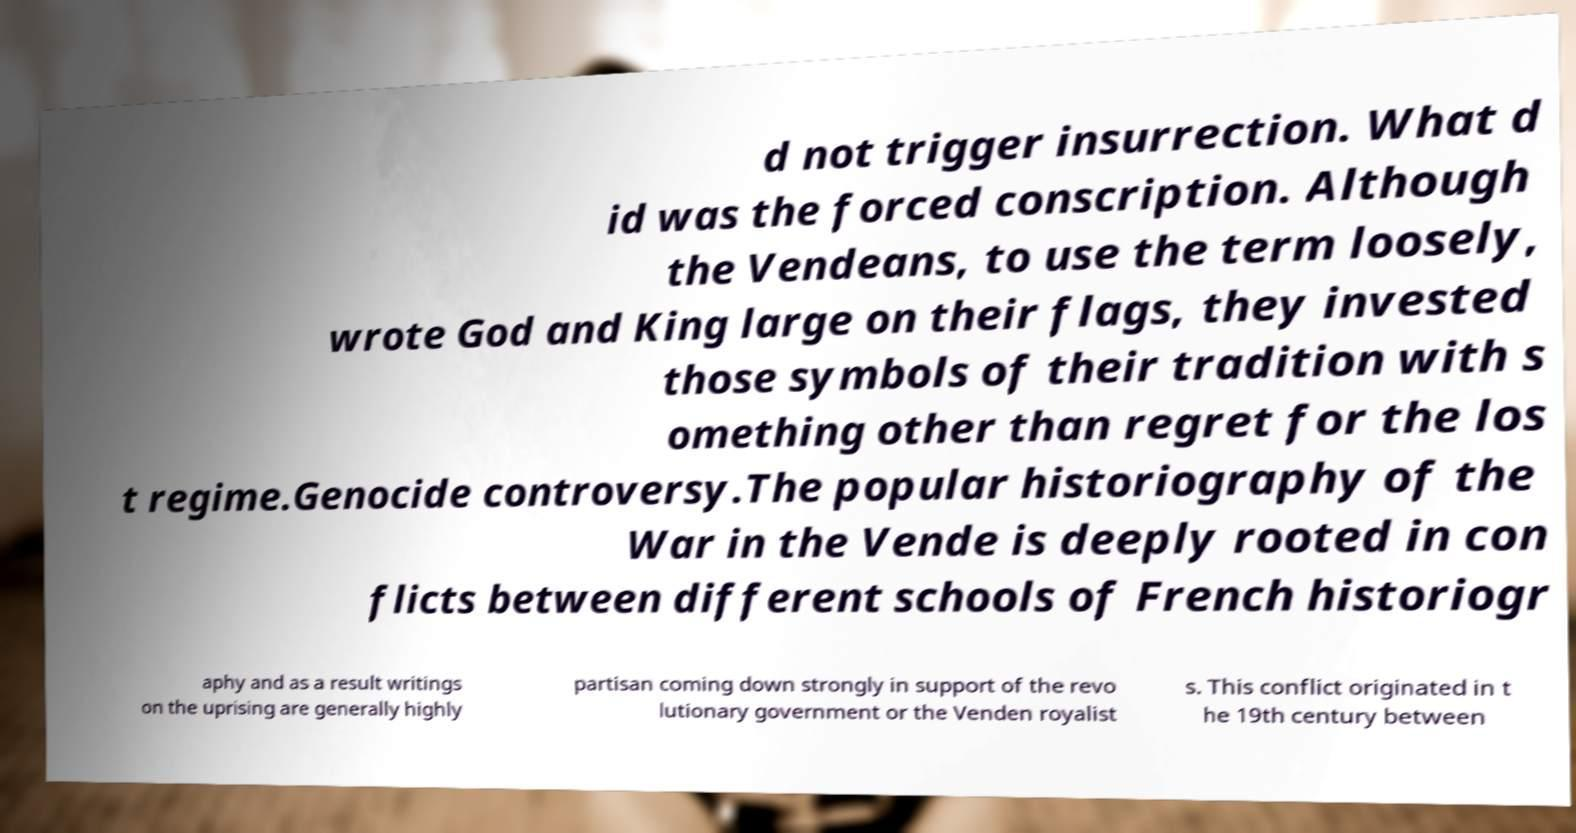Can you read and provide the text displayed in the image?This photo seems to have some interesting text. Can you extract and type it out for me? d not trigger insurrection. What d id was the forced conscription. Although the Vendeans, to use the term loosely, wrote God and King large on their flags, they invested those symbols of their tradition with s omething other than regret for the los t regime.Genocide controversy.The popular historiography of the War in the Vende is deeply rooted in con flicts between different schools of French historiogr aphy and as a result writings on the uprising are generally highly partisan coming down strongly in support of the revo lutionary government or the Venden royalist s. This conflict originated in t he 19th century between 